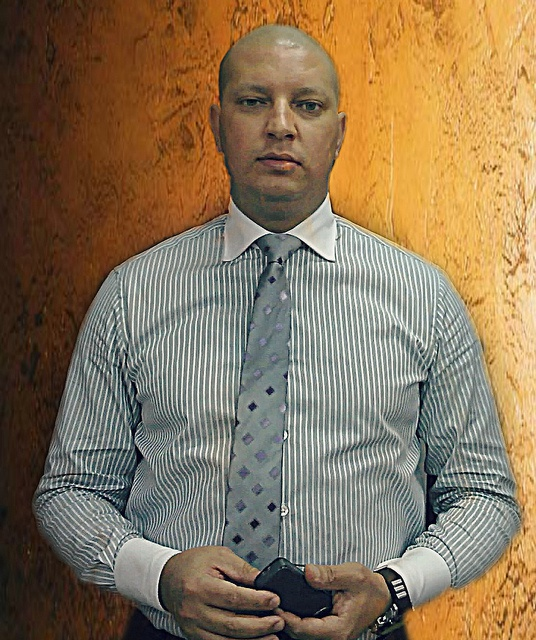Describe the objects in this image and their specific colors. I can see people in black, gray, darkgray, and lightgray tones, tie in black and gray tones, cell phone in black, gray, purple, and darkblue tones, and clock in black, gray, and white tones in this image. 